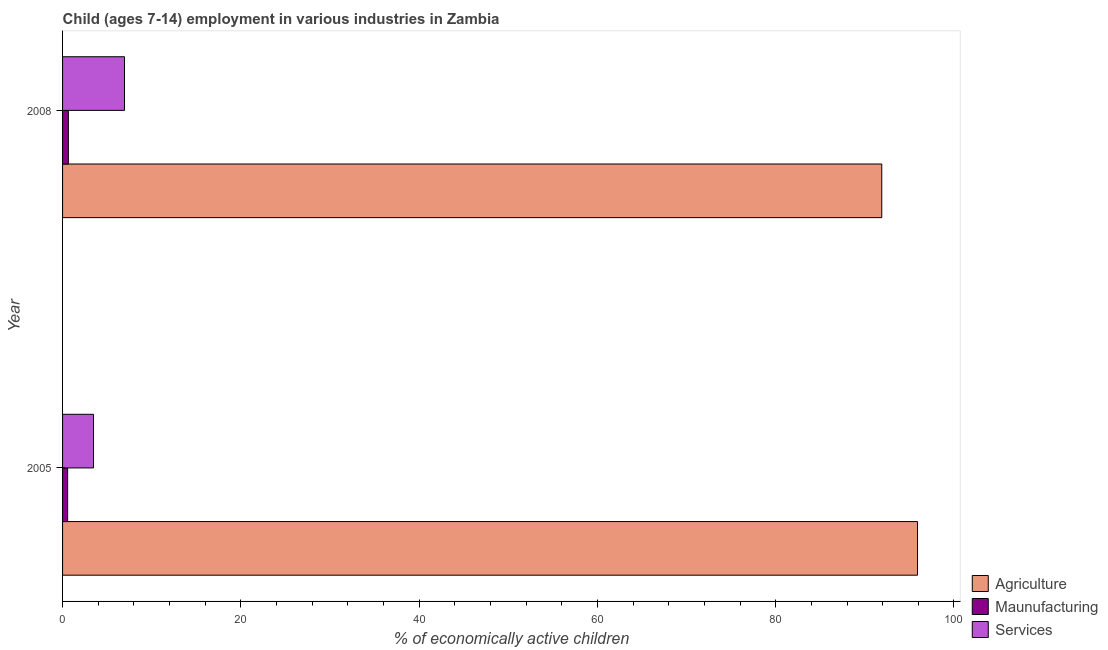Are the number of bars per tick equal to the number of legend labels?
Keep it short and to the point. Yes. How many bars are there on the 2nd tick from the bottom?
Provide a succinct answer. 3. What is the label of the 2nd group of bars from the top?
Make the answer very short. 2005. What is the percentage of economically active children in agriculture in 2008?
Offer a terse response. 91.9. Across all years, what is the maximum percentage of economically active children in manufacturing?
Your answer should be compact. 0.65. Across all years, what is the minimum percentage of economically active children in services?
Give a very brief answer. 3.47. In which year was the percentage of economically active children in manufacturing minimum?
Provide a succinct answer. 2005. What is the total percentage of economically active children in services in the graph?
Offer a very short reply. 10.42. What is the difference between the percentage of economically active children in agriculture in 2005 and that in 2008?
Your answer should be very brief. 4.01. What is the difference between the percentage of economically active children in manufacturing in 2008 and the percentage of economically active children in agriculture in 2005?
Provide a succinct answer. -95.26. What is the average percentage of economically active children in services per year?
Make the answer very short. 5.21. What is the ratio of the percentage of economically active children in agriculture in 2005 to that in 2008?
Keep it short and to the point. 1.04. What does the 2nd bar from the top in 2008 represents?
Give a very brief answer. Maunufacturing. What does the 2nd bar from the bottom in 2005 represents?
Your answer should be very brief. Maunufacturing. Is it the case that in every year, the sum of the percentage of economically active children in agriculture and percentage of economically active children in manufacturing is greater than the percentage of economically active children in services?
Offer a very short reply. Yes. How many bars are there?
Your answer should be very brief. 6. Does the graph contain any zero values?
Provide a short and direct response. No. Does the graph contain grids?
Your response must be concise. No. How many legend labels are there?
Provide a short and direct response. 3. How are the legend labels stacked?
Your response must be concise. Vertical. What is the title of the graph?
Make the answer very short. Child (ages 7-14) employment in various industries in Zambia. Does "Primary" appear as one of the legend labels in the graph?
Your answer should be very brief. No. What is the label or title of the X-axis?
Ensure brevity in your answer.  % of economically active children. What is the % of economically active children in Agriculture in 2005?
Provide a succinct answer. 95.91. What is the % of economically active children of Maunufacturing in 2005?
Your answer should be very brief. 0.57. What is the % of economically active children of Services in 2005?
Your answer should be compact. 3.47. What is the % of economically active children in Agriculture in 2008?
Provide a short and direct response. 91.9. What is the % of economically active children of Maunufacturing in 2008?
Provide a short and direct response. 0.65. What is the % of economically active children of Services in 2008?
Provide a short and direct response. 6.95. Across all years, what is the maximum % of economically active children of Agriculture?
Your answer should be very brief. 95.91. Across all years, what is the maximum % of economically active children in Maunufacturing?
Provide a succinct answer. 0.65. Across all years, what is the maximum % of economically active children of Services?
Ensure brevity in your answer.  6.95. Across all years, what is the minimum % of economically active children in Agriculture?
Your response must be concise. 91.9. Across all years, what is the minimum % of economically active children in Maunufacturing?
Give a very brief answer. 0.57. Across all years, what is the minimum % of economically active children in Services?
Your answer should be very brief. 3.47. What is the total % of economically active children of Agriculture in the graph?
Offer a terse response. 187.81. What is the total % of economically active children in Maunufacturing in the graph?
Provide a succinct answer. 1.22. What is the total % of economically active children in Services in the graph?
Your response must be concise. 10.42. What is the difference between the % of economically active children of Agriculture in 2005 and that in 2008?
Make the answer very short. 4.01. What is the difference between the % of economically active children in Maunufacturing in 2005 and that in 2008?
Your answer should be very brief. -0.08. What is the difference between the % of economically active children of Services in 2005 and that in 2008?
Your answer should be compact. -3.48. What is the difference between the % of economically active children in Agriculture in 2005 and the % of economically active children in Maunufacturing in 2008?
Offer a very short reply. 95.26. What is the difference between the % of economically active children of Agriculture in 2005 and the % of economically active children of Services in 2008?
Offer a terse response. 88.96. What is the difference between the % of economically active children in Maunufacturing in 2005 and the % of economically active children in Services in 2008?
Provide a succinct answer. -6.38. What is the average % of economically active children of Agriculture per year?
Provide a succinct answer. 93.91. What is the average % of economically active children in Maunufacturing per year?
Your answer should be compact. 0.61. What is the average % of economically active children in Services per year?
Your response must be concise. 5.21. In the year 2005, what is the difference between the % of economically active children of Agriculture and % of economically active children of Maunufacturing?
Keep it short and to the point. 95.34. In the year 2005, what is the difference between the % of economically active children of Agriculture and % of economically active children of Services?
Provide a succinct answer. 92.44. In the year 2008, what is the difference between the % of economically active children of Agriculture and % of economically active children of Maunufacturing?
Your answer should be very brief. 91.25. In the year 2008, what is the difference between the % of economically active children in Agriculture and % of economically active children in Services?
Provide a succinct answer. 84.95. In the year 2008, what is the difference between the % of economically active children in Maunufacturing and % of economically active children in Services?
Keep it short and to the point. -6.3. What is the ratio of the % of economically active children of Agriculture in 2005 to that in 2008?
Offer a very short reply. 1.04. What is the ratio of the % of economically active children in Maunufacturing in 2005 to that in 2008?
Offer a very short reply. 0.88. What is the ratio of the % of economically active children in Services in 2005 to that in 2008?
Give a very brief answer. 0.5. What is the difference between the highest and the second highest % of economically active children of Agriculture?
Provide a succinct answer. 4.01. What is the difference between the highest and the second highest % of economically active children of Services?
Provide a short and direct response. 3.48. What is the difference between the highest and the lowest % of economically active children in Agriculture?
Provide a succinct answer. 4.01. What is the difference between the highest and the lowest % of economically active children of Services?
Provide a succinct answer. 3.48. 